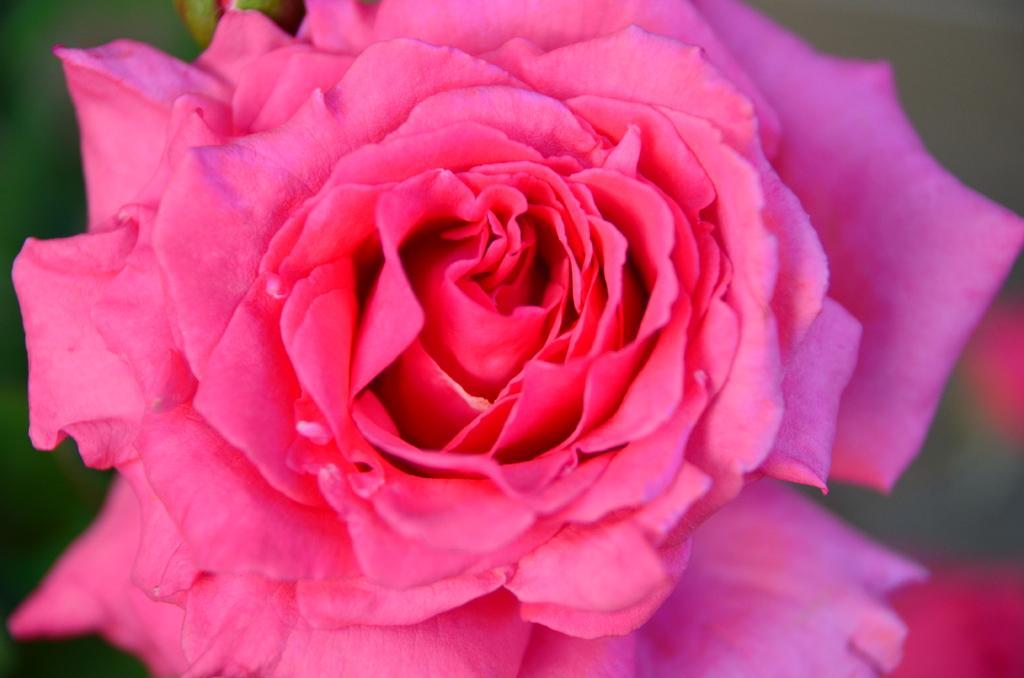Can you describe this image briefly? In this image we can see a rose which is in pink color. 